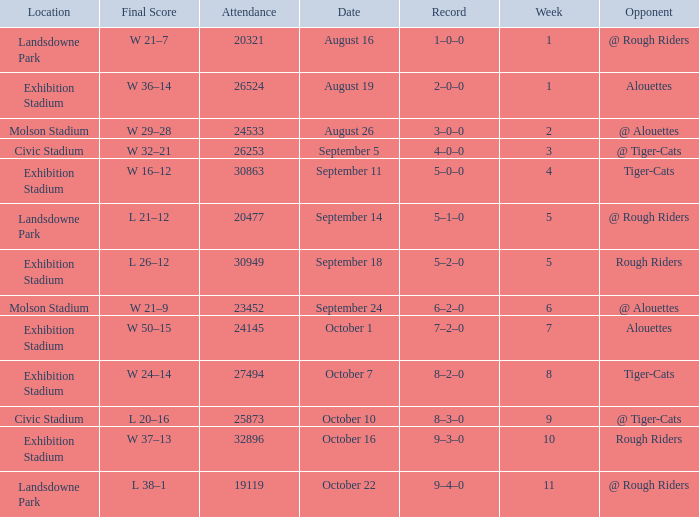How many values for attendance on the date of September 5? 1.0. 